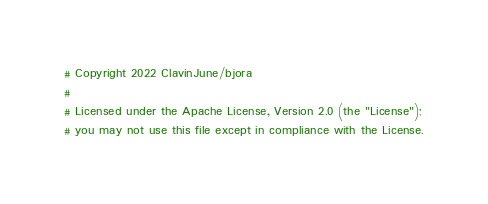Convert code to text. <code><loc_0><loc_0><loc_500><loc_500><_YAML_># Copyright 2022 ClavinJune/bjora
#
# Licensed under the Apache License, Version 2.0 (the "License");
# you may not use this file except in compliance with the License.</code> 